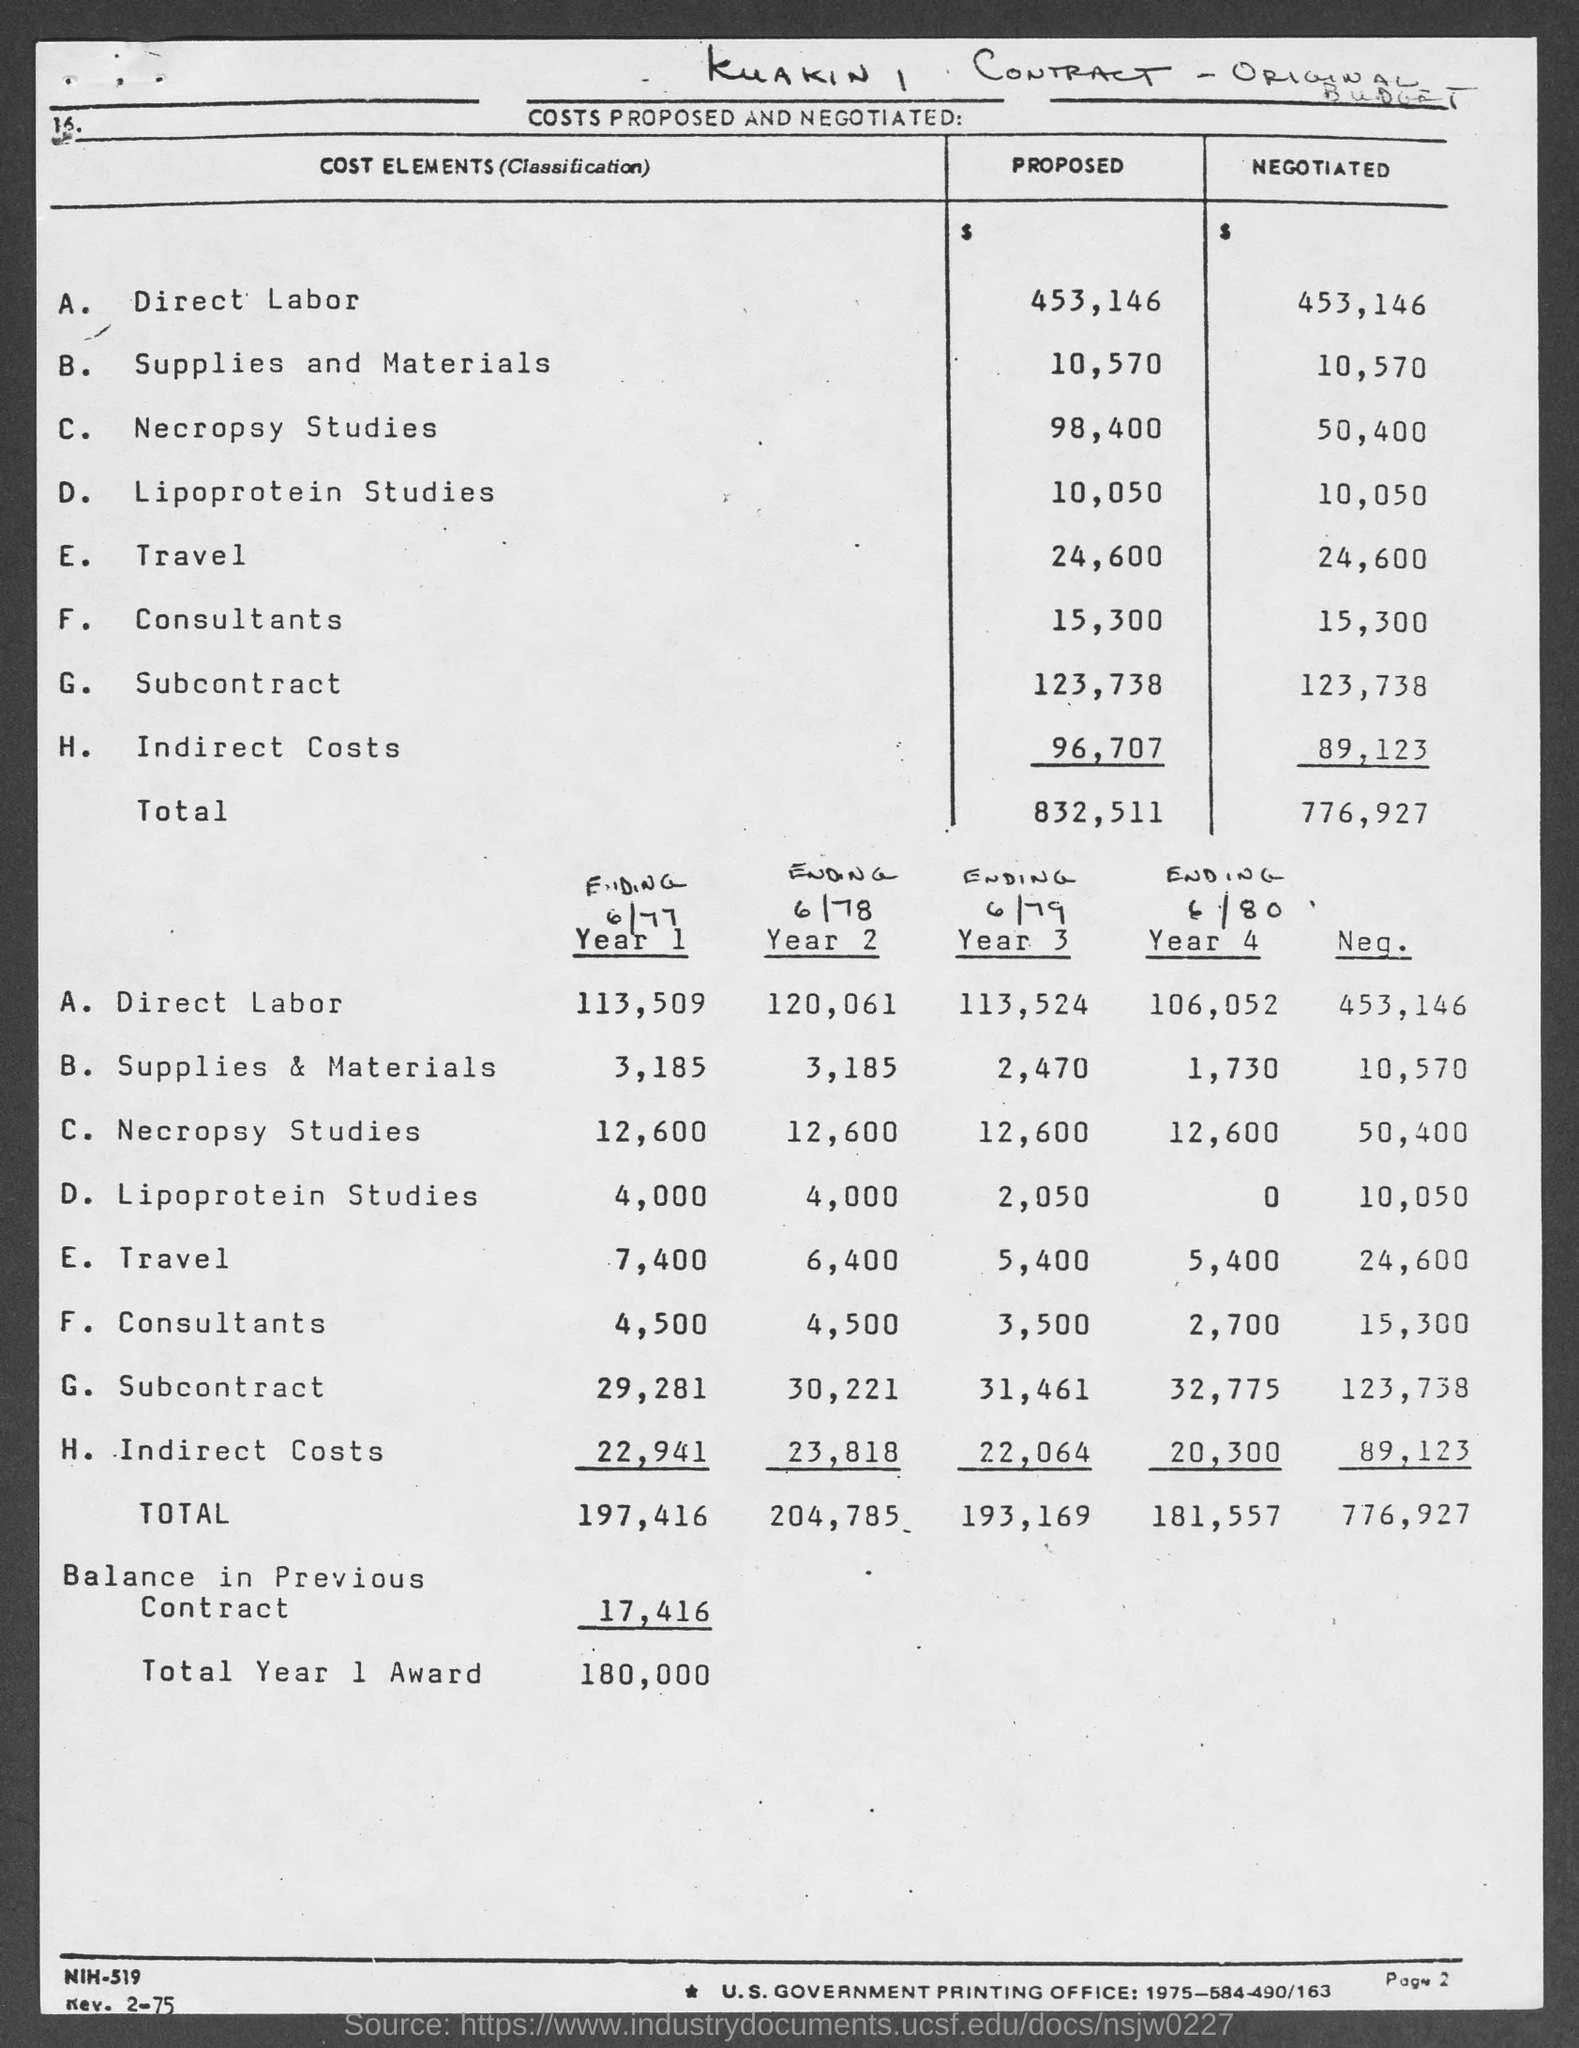Identify some key points in this picture. The total proposed costs mentioned in the given table are 832,511... The proposed cost for necropsy studies is $98,400. The proposed cost for lipoprotein studies is 10,050. The proposed cost for direct labor is 453,146. The estimated cost for consultants is 15,300. 